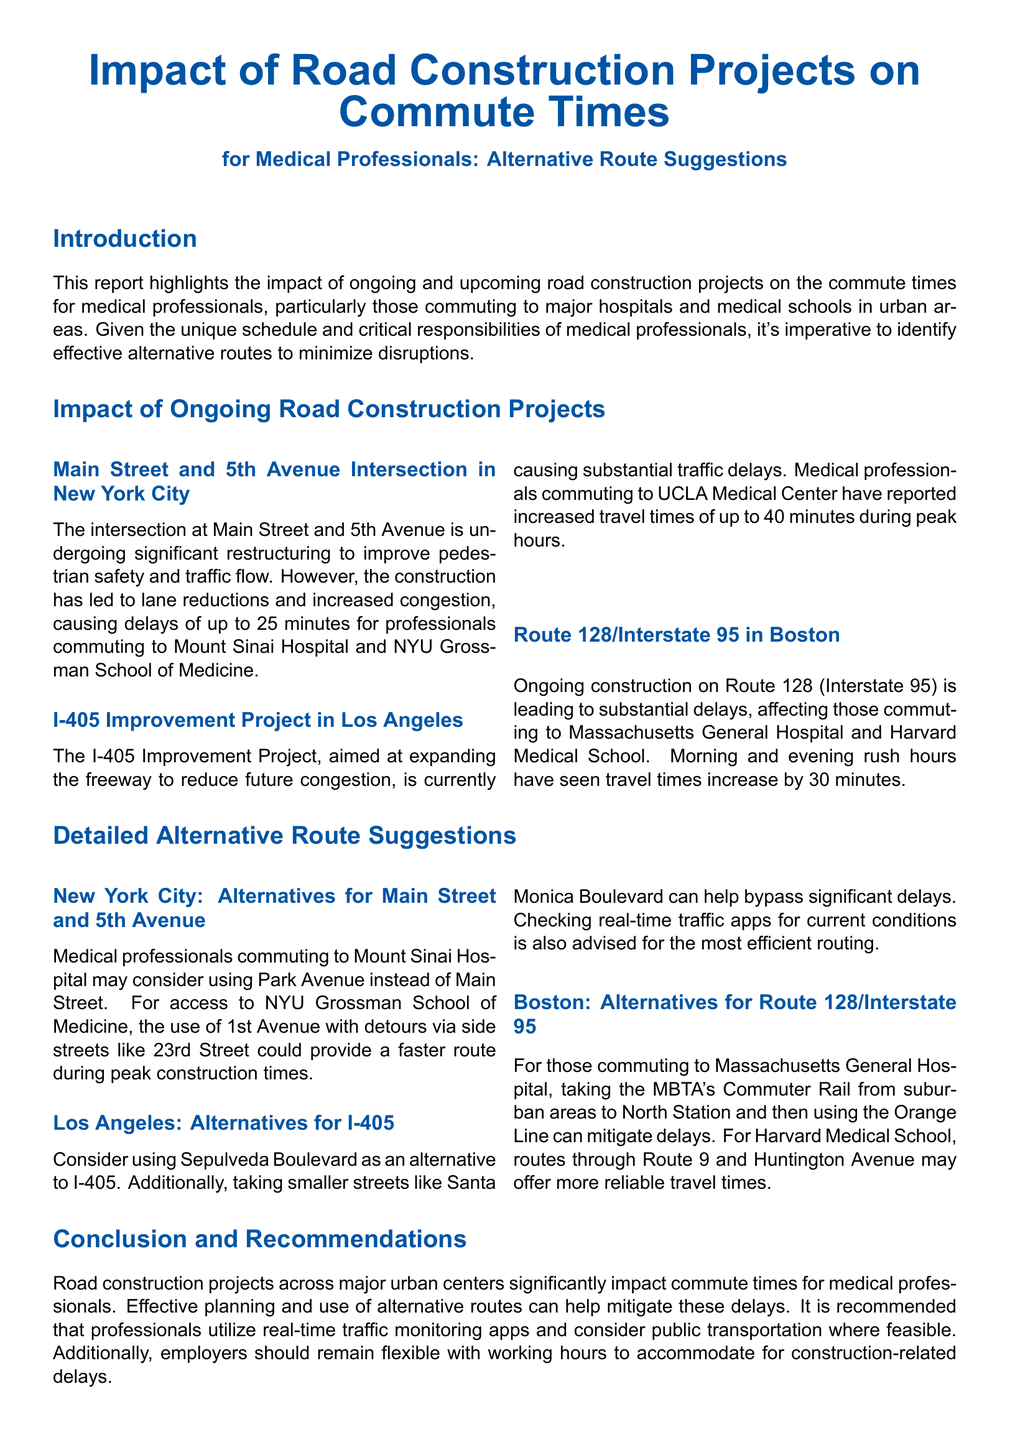What is the impact on commute times for medical professionals in New York City due to the construction? The construction at Main Street and 5th Avenue has led to delays of up to 25 minutes for professionals commuting to Mount Sinai Hospital and NYU Grossman School of Medicine.
Answer: 25 minutes What construction project is currently affecting travel times for UCLA Medical Center employees? The I-405 Improvement Project is causing substantial traffic delays for those commuting to UCLA Medical Center.
Answer: I-405 Improvement Project What alternative route is suggested for medical professionals commuting to Mount Sinai Hospital? Medical professionals may consider using Park Avenue instead of Main Street as an alternative route.
Answer: Park Avenue How much increased travel time is reported during peak hours for the I-405 Improvement Project? Increased travel times of up to 40 minutes have been reported during peak hours for the I-405 Improvement Project.
Answer: 40 minutes Which public transportation option is recommended for commuting to Massachusetts General Hospital? Taking the MBTA's Commuter Rail to North Station is recommended for Massachusetts General Hospital commutes.
Answer: MBTA's Commuter Rail What is the main purpose of the report? The report highlights the impact of ongoing and upcoming road construction projects on the commute times for medical professionals.
Answer: Impact on commute times What time of day has seen substantial delays for Route 128/Interstate 95 commuters? Morning and evening rush hours have seen substantial delays for commuters.
Answer: Morning and evening rush hours What should medical professionals consider using to avoid construction-related delays? Professionals should utilize real-time traffic monitoring apps to avoid delays.
Answer: Real-time traffic monitoring apps How does the report recommend employers respond to construction-related delays? The report recommends that employers remain flexible with working hours to accommodate construction-related delays.
Answer: Flexible working hours 